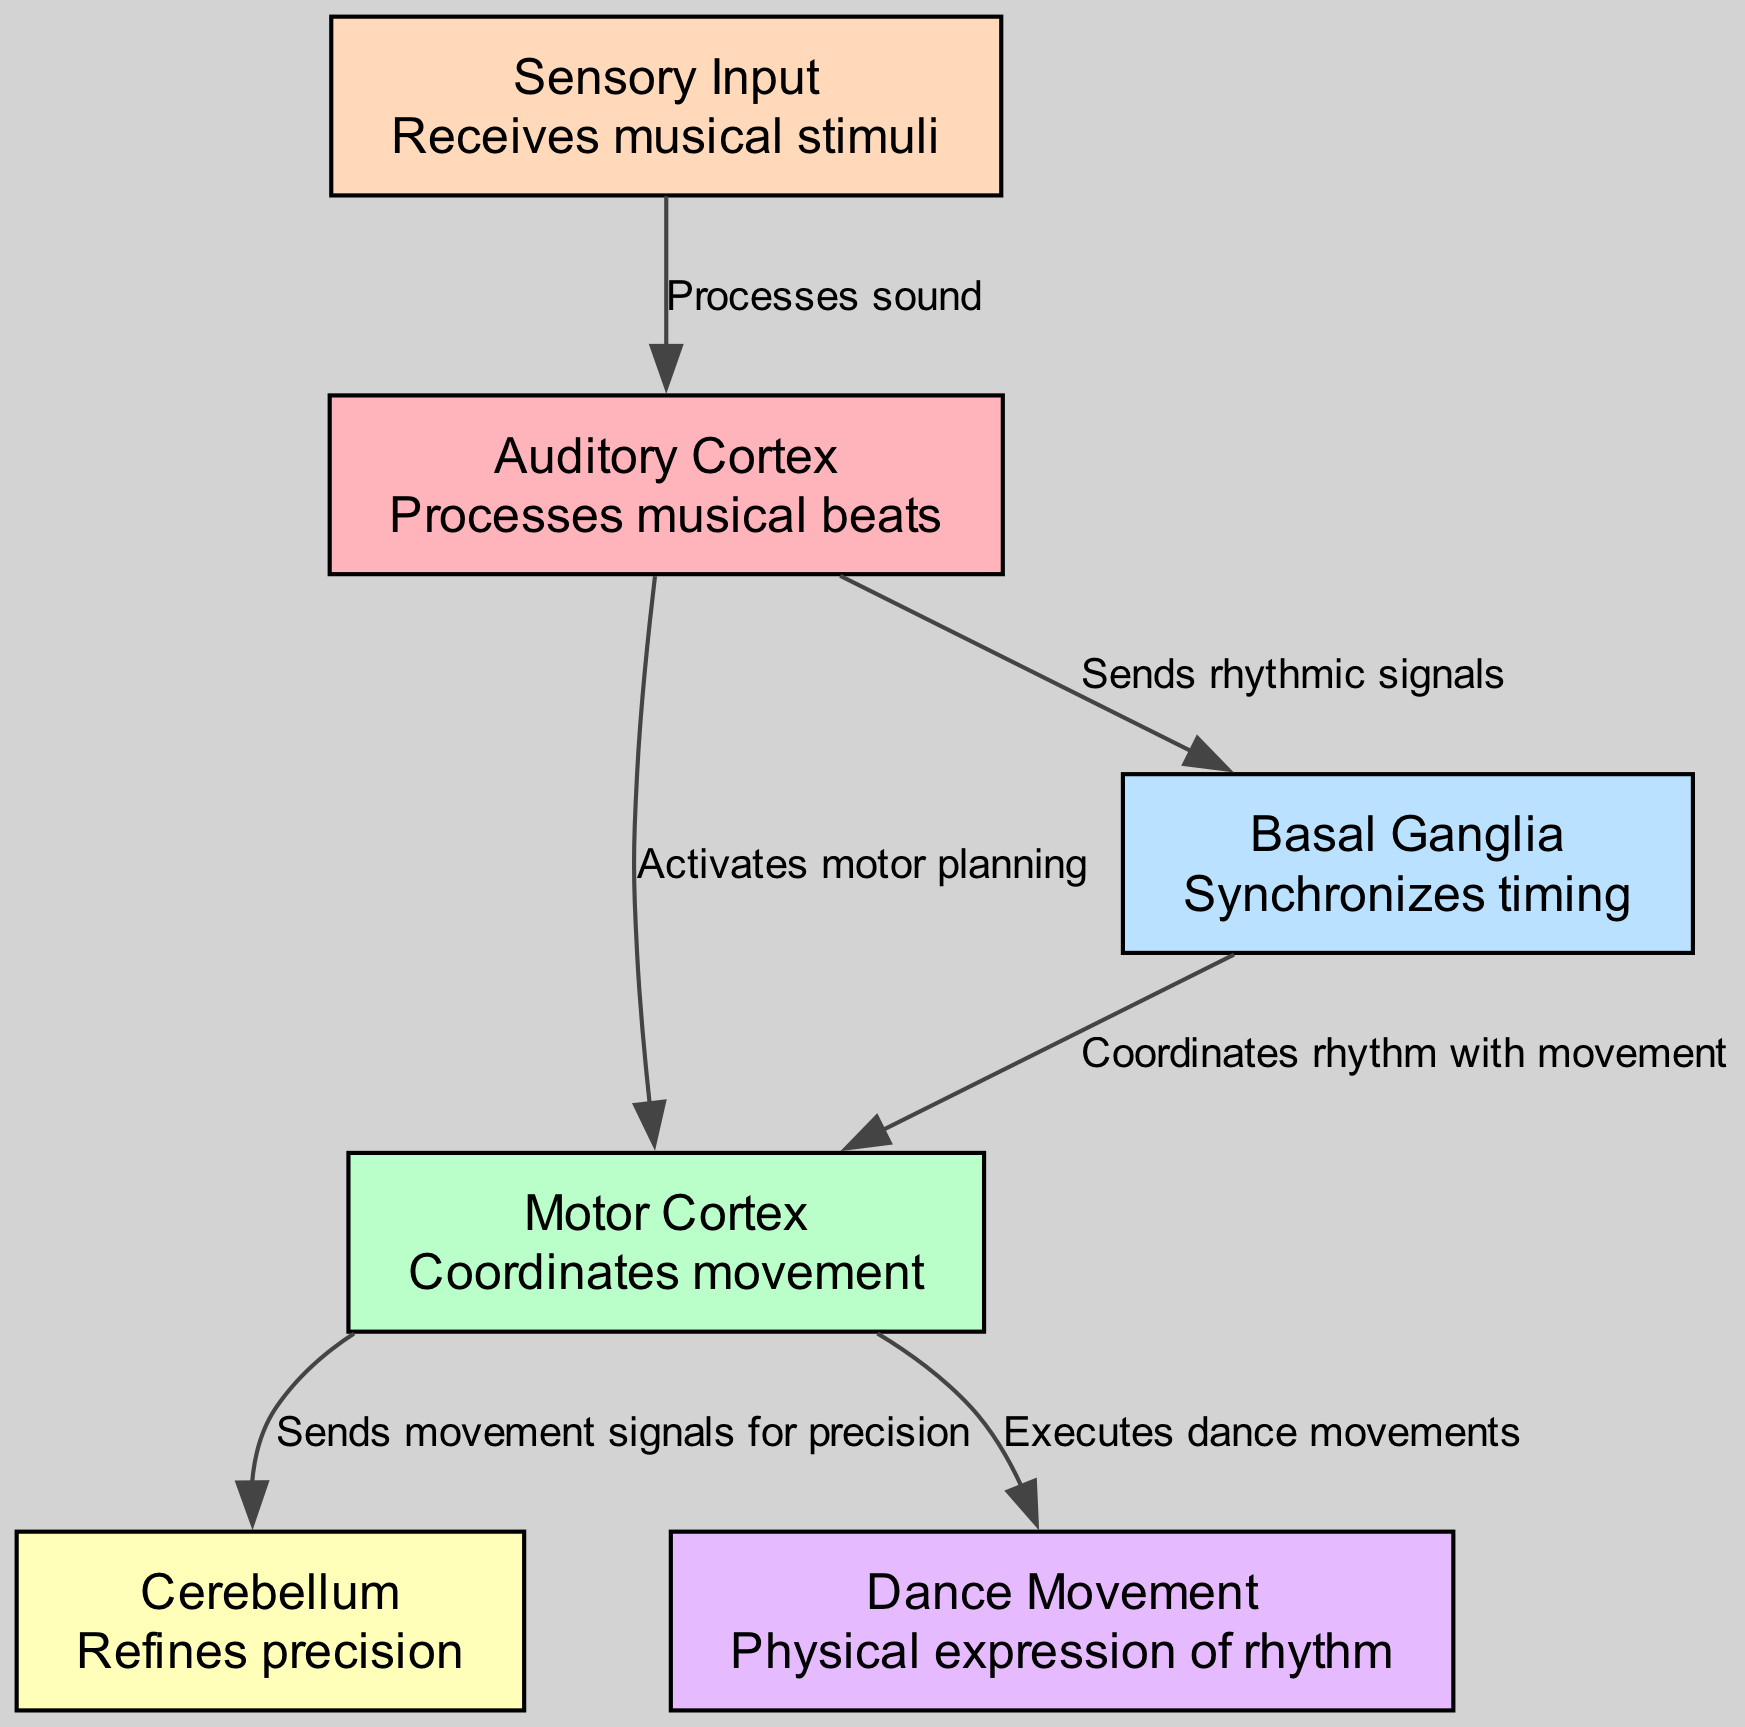What are the two main cortices involved in processing dance movements? The diagram shows the "Auditory Cortex" and "Motor Cortex" as key nodes connected in the process of translating musical beats into dance movements.
Answer: Auditory Cortex, Motor Cortex How many nodes are present in the diagram? The diagram lists a total of six nodes: Auditory Cortex, Motor Cortex, Basal Ganglia, Cerebellum, Sensory Input, and Dance Movement.
Answer: 6 What does the Basal Ganglia do in relation to rhythm? The diagram indicates that the Basal Ganglia synchronizes timing, acting as a critical component that connects auditory signals to movement coordination.
Answer: Synchronizes timing Which part of the brain sends movement signals for precision? According to the connections shown in the diagram, the "Motor Cortex" sends signals to the "Cerebellum," which refines precision in dance movements.
Answer: Motor Cortex How is sensory input processed according to the diagram? The diagram illustrates that sensory input is received, processes sound in the Auditory Cortex, and then transforms into rhythmic signals that further engage the Motor Cortex.
Answer: Processes sound What is the final output of the brain's process represented in the diagram? The diagram concludes with "Dance Movement," indicating that the physical expression of rhythm is the end result of the brain's processing of musical beats and timing.
Answer: Dance Movement Which two nodes are directly connected to the Motor Cortex? The diagram shows that the Motor Cortex is directly connected to both the Cerebellum and Dance Movement, illustrating its role in both precision and execution of movements.
Answer: Cerebellum, Dance Movement What relationship exists between the Auditory Cortex and the Basal Ganglia? The diagram depicts that the Auditory Cortex sends rhythmic signals to the Basal Ganglia, highlighting the flow from auditory processing to timing synchronization.
Answer: Sends rhythmic signals Which node represents the input of musical stimuli? As per the diagram, the node labeled "Sensory Input" is responsible for receiving the musical stimuli that initiate the processing sequence.
Answer: Sensory Input 